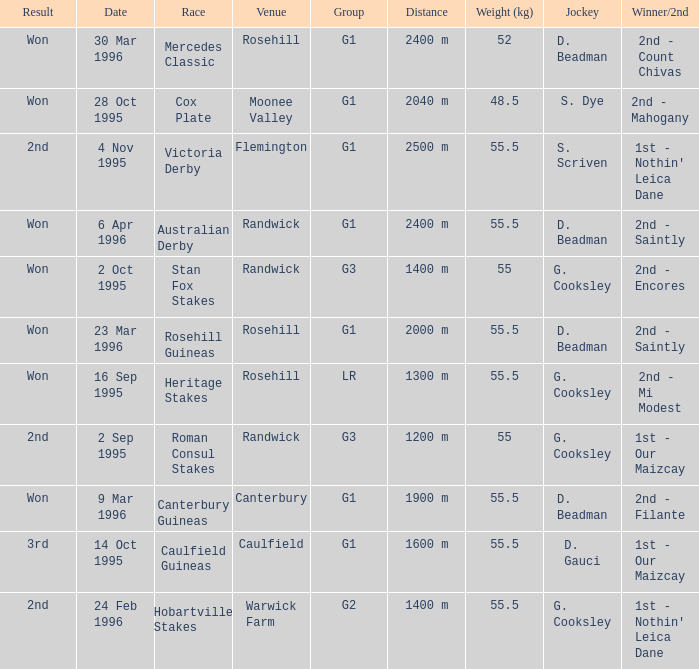What venue hosted the stan fox stakes? Randwick. 